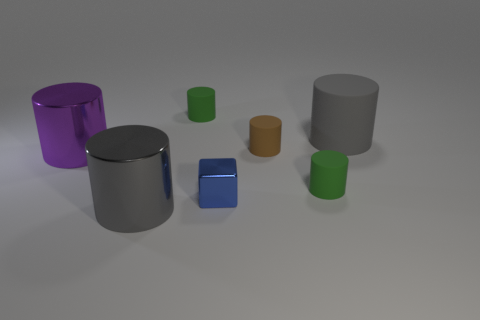Add 3 small green cylinders. How many objects exist? 10 Subtract all large purple cylinders. How many cylinders are left? 5 Subtract all blocks. How many objects are left? 6 Subtract all gray cylinders. How many cylinders are left? 4 Subtract 1 brown cylinders. How many objects are left? 6 Subtract 1 cylinders. How many cylinders are left? 5 Subtract all purple cylinders. Subtract all red cubes. How many cylinders are left? 5 Subtract all brown cubes. How many green cylinders are left? 2 Subtract all green rubber things. Subtract all matte things. How many objects are left? 1 Add 7 brown matte objects. How many brown matte objects are left? 8 